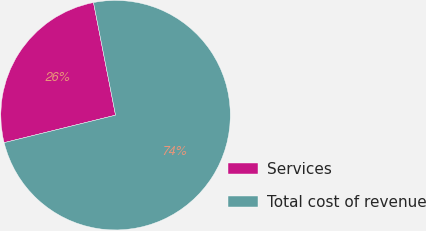<chart> <loc_0><loc_0><loc_500><loc_500><pie_chart><fcel>Services<fcel>Total cost of revenue<nl><fcel>25.77%<fcel>74.23%<nl></chart> 